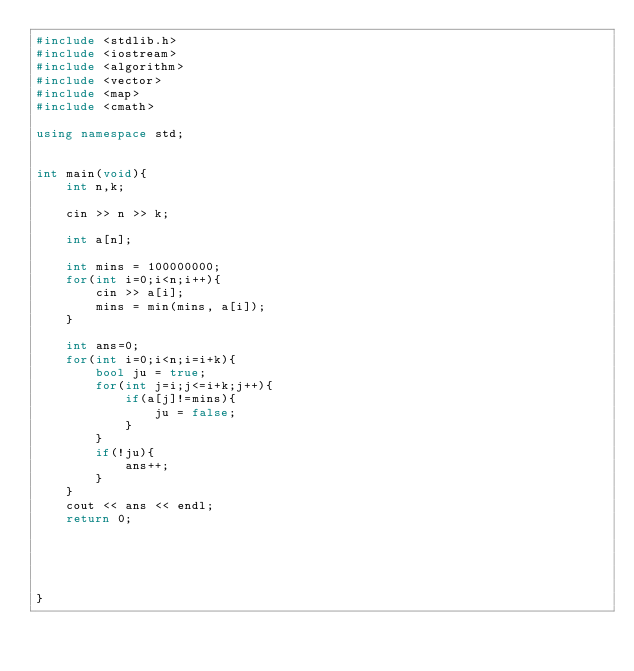<code> <loc_0><loc_0><loc_500><loc_500><_C++_>#include <stdlib.h>
#include <iostream>
#include <algorithm>
#include <vector>
#include <map>
#include <cmath>

using namespace std;


int main(void){
    int n,k;

    cin >> n >> k;

    int a[n];

    int mins = 100000000;
    for(int i=0;i<n;i++){
        cin >> a[i];
        mins = min(mins, a[i]);
    }

    int ans=0;
    for(int i=0;i<n;i=i+k){
        bool ju = true;
        for(int j=i;j<=i+k;j++){
            if(a[j]!=mins){
                ju = false;
            }
        }
        if(!ju){
            ans++;
        }
    }
    cout << ans << endl;
    return 0;

    

    
    
}</code> 